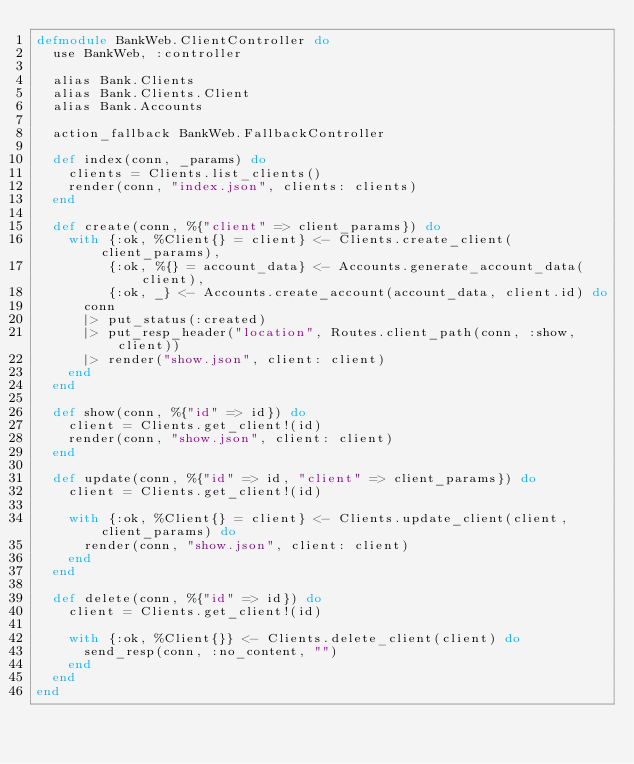<code> <loc_0><loc_0><loc_500><loc_500><_Elixir_>defmodule BankWeb.ClientController do
  use BankWeb, :controller

  alias Bank.Clients
  alias Bank.Clients.Client
  alias Bank.Accounts

  action_fallback BankWeb.FallbackController

  def index(conn, _params) do
    clients = Clients.list_clients()
    render(conn, "index.json", clients: clients)
  end

  def create(conn, %{"client" => client_params}) do
    with {:ok, %Client{} = client} <- Clients.create_client(client_params),
         {:ok, %{} = account_data} <- Accounts.generate_account_data(client),
         {:ok, _} <- Accounts.create_account(account_data, client.id) do
      conn
      |> put_status(:created)
      |> put_resp_header("location", Routes.client_path(conn, :show, client))
      |> render("show.json", client: client)
    end
  end

  def show(conn, %{"id" => id}) do
    client = Clients.get_client!(id)
    render(conn, "show.json", client: client)
  end

  def update(conn, %{"id" => id, "client" => client_params}) do
    client = Clients.get_client!(id)

    with {:ok, %Client{} = client} <- Clients.update_client(client, client_params) do
      render(conn, "show.json", client: client)
    end
  end

  def delete(conn, %{"id" => id}) do
    client = Clients.get_client!(id)

    with {:ok, %Client{}} <- Clients.delete_client(client) do
      send_resp(conn, :no_content, "")
    end
  end
end
</code> 